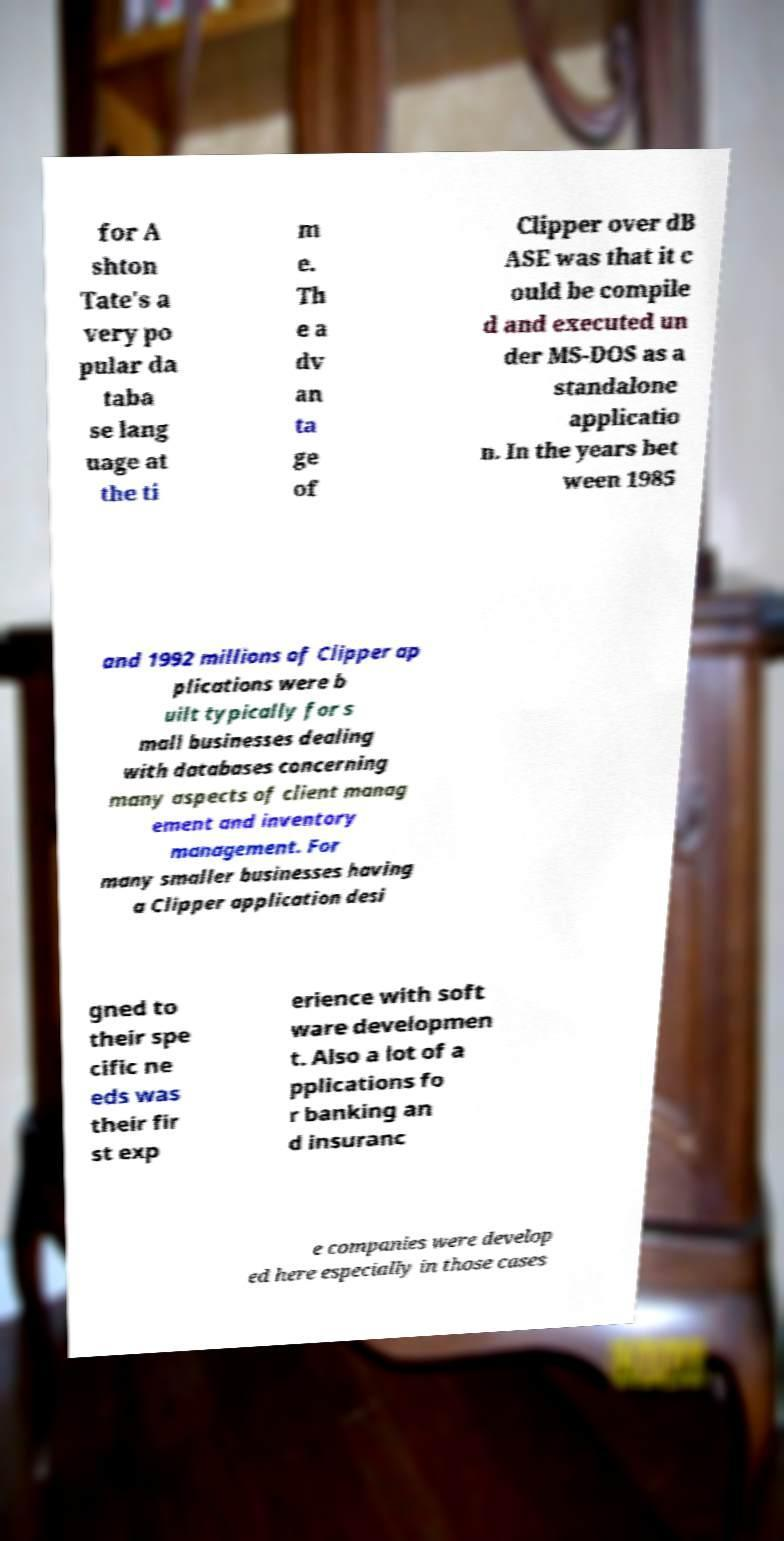Please read and relay the text visible in this image. What does it say? for A shton Tate's a very po pular da taba se lang uage at the ti m e. Th e a dv an ta ge of Clipper over dB ASE was that it c ould be compile d and executed un der MS-DOS as a standalone applicatio n. In the years bet ween 1985 and 1992 millions of Clipper ap plications were b uilt typically for s mall businesses dealing with databases concerning many aspects of client manag ement and inventory management. For many smaller businesses having a Clipper application desi gned to their spe cific ne eds was their fir st exp erience with soft ware developmen t. Also a lot of a pplications fo r banking an d insuranc e companies were develop ed here especially in those cases 